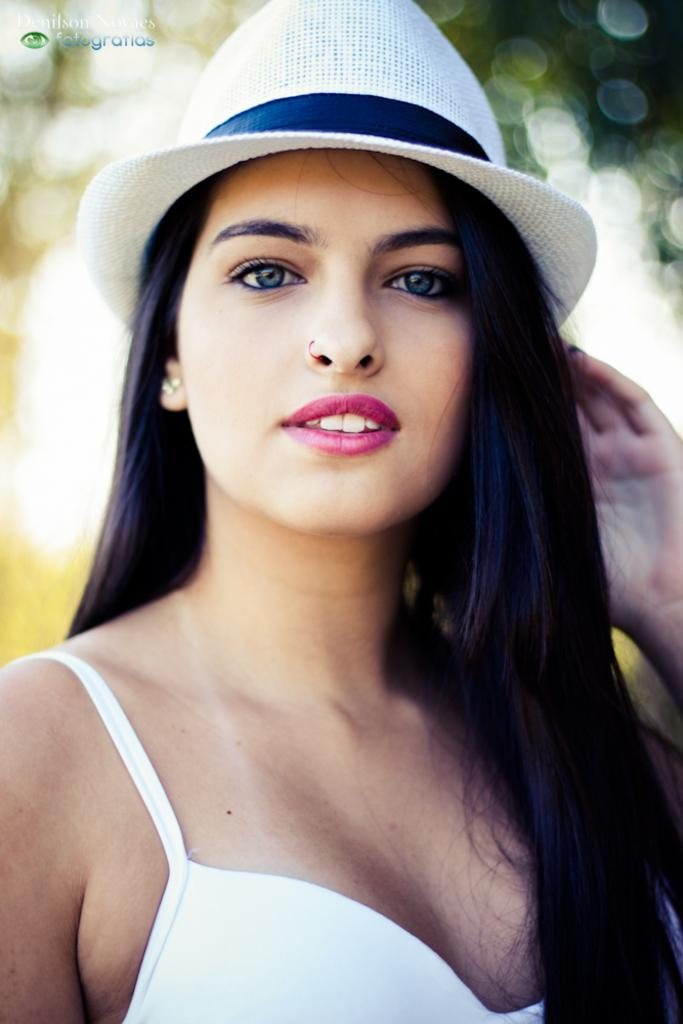Who is present in the image? There is a woman in the image. What is the woman doing in the image? The woman is standing and smiling. What is the woman wearing on her head? The woman is wearing a hat. Can you describe the background of the image? The background of the image is blurred. What type of soup is the woman holding in the image? There is no soup present in the image; the woman is not holding anything. How many oranges can be seen in the image? There are no oranges present in the image. 